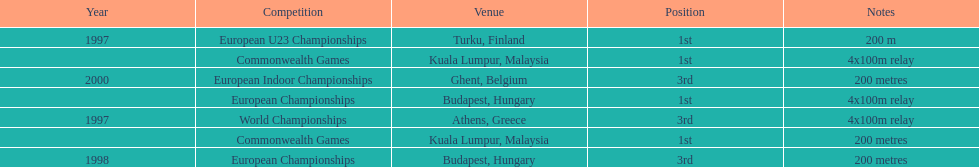List the other competitions besides european u23 championship that came in 1st position? European Championships, Commonwealth Games, Commonwealth Games. 